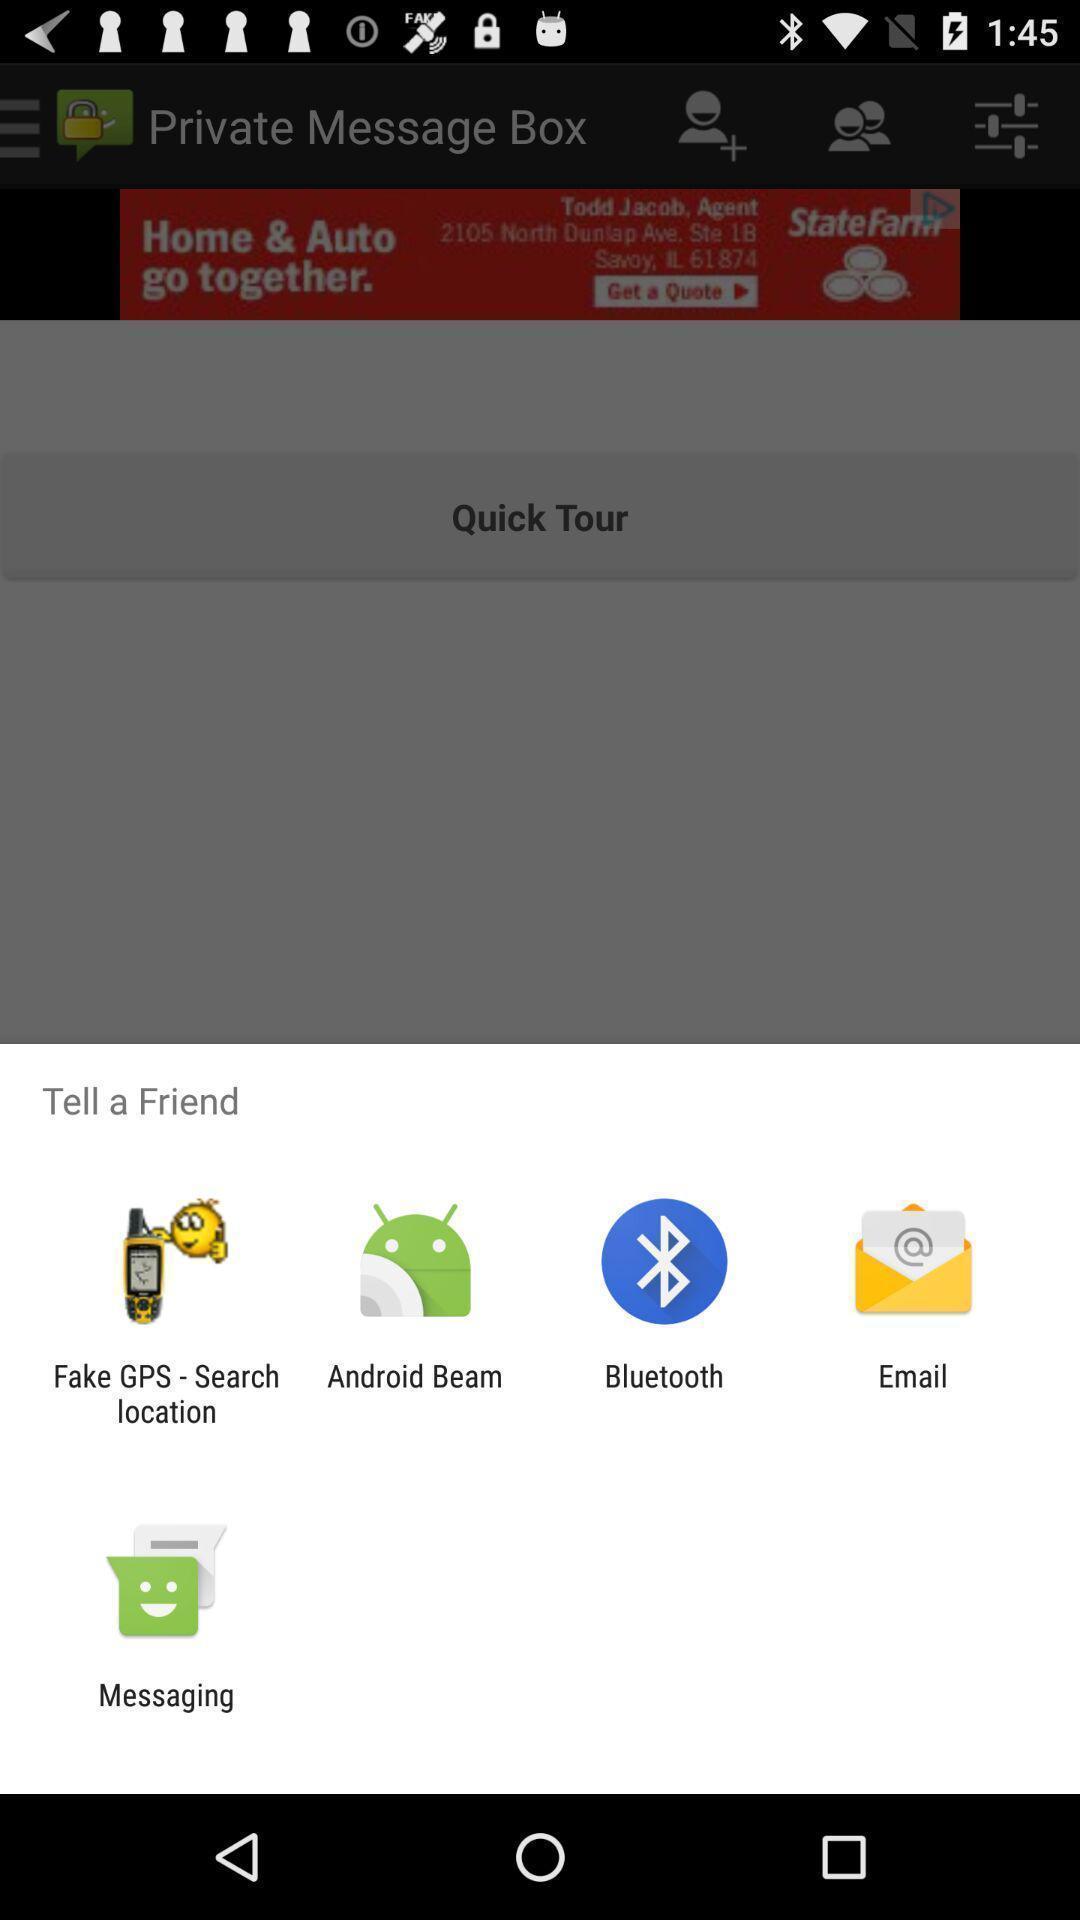Describe this image in words. Pop up window of share option. 